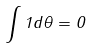<formula> <loc_0><loc_0><loc_500><loc_500>\int 1 d \theta = 0</formula> 